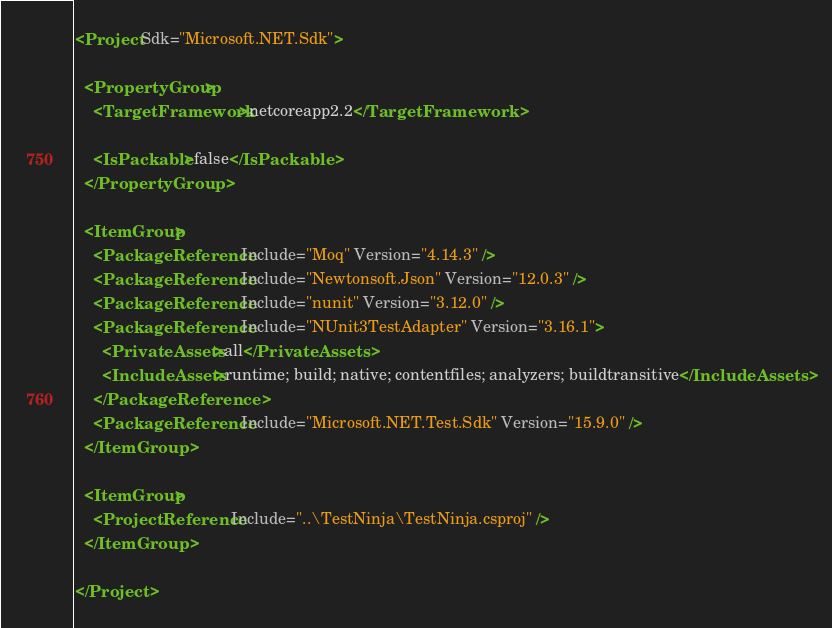Convert code to text. <code><loc_0><loc_0><loc_500><loc_500><_XML_><Project Sdk="Microsoft.NET.Sdk">

  <PropertyGroup>
    <TargetFramework>netcoreapp2.2</TargetFramework>

    <IsPackable>false</IsPackable>
  </PropertyGroup>

  <ItemGroup>
    <PackageReference Include="Moq" Version="4.14.3" />
    <PackageReference Include="Newtonsoft.Json" Version="12.0.3" />
    <PackageReference Include="nunit" Version="3.12.0" />
    <PackageReference Include="NUnit3TestAdapter" Version="3.16.1">
      <PrivateAssets>all</PrivateAssets>
      <IncludeAssets>runtime; build; native; contentfiles; analyzers; buildtransitive</IncludeAssets>
    </PackageReference>
    <PackageReference Include="Microsoft.NET.Test.Sdk" Version="15.9.0" />
  </ItemGroup>

  <ItemGroup>
    <ProjectReference Include="..\TestNinja\TestNinja.csproj" />
  </ItemGroup>

</Project>
</code> 